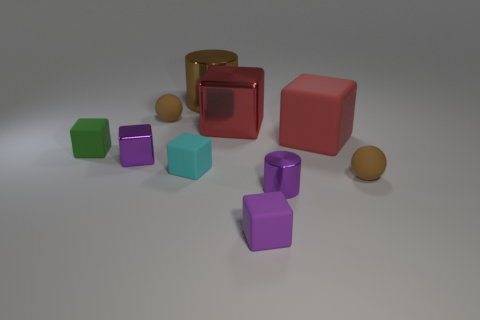What is the size of the red metallic block?
Your answer should be compact. Large. How many matte objects are the same color as the big metallic cylinder?
Your answer should be very brief. 2. There is a brown rubber thing that is on the right side of the small brown matte sphere that is behind the red matte object; are there any red shiny cubes left of it?
Your response must be concise. Yes. What is the shape of the matte object that is the same size as the red shiny cube?
Your response must be concise. Cube. What number of small things are gray metal balls or brown cylinders?
Your response must be concise. 0. The big cylinder that is made of the same material as the tiny purple cylinder is what color?
Provide a succinct answer. Brown. Is the shape of the tiny matte object that is behind the tiny green object the same as the small brown rubber object that is in front of the red matte thing?
Your answer should be very brief. Yes. How many rubber objects are large blocks or small objects?
Offer a terse response. 6. There is another cube that is the same color as the large metallic cube; what is its material?
Give a very brief answer. Rubber. Is there anything else that is the same shape as the big matte object?
Offer a terse response. Yes. 